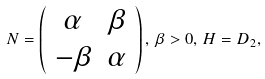<formula> <loc_0><loc_0><loc_500><loc_500>N = \left ( \begin{array} { c c } \alpha & \beta \\ - \beta & \alpha \end{array} \right ) , \, \beta > 0 , \, H = D _ { 2 } ,</formula> 